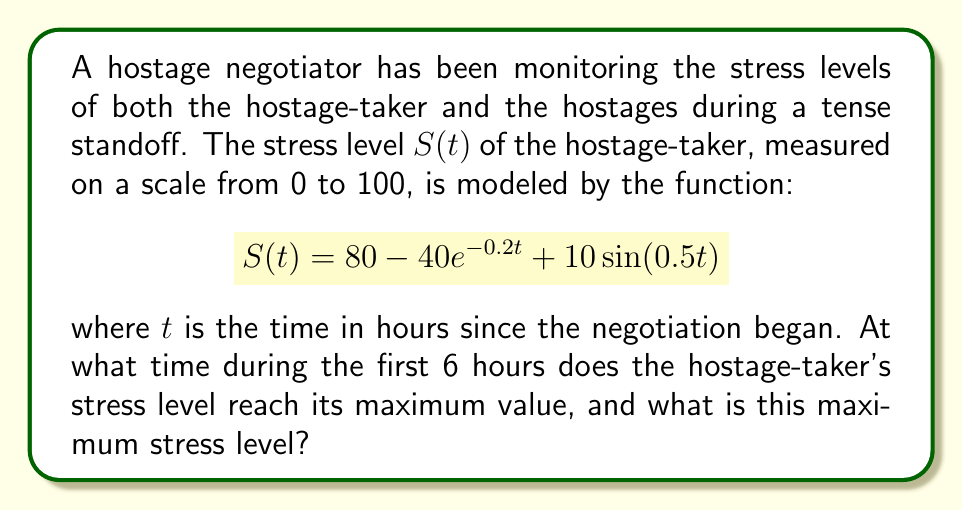Can you solve this math problem? To find the maximum stress level and when it occurs, we need to follow these steps:

1) First, we need to find the derivative of $S(t)$ with respect to $t$:
   $$S'(t) = 8e^{-0.2t} + 5\cos(0.5t)$$

2) To find the critical points, we set $S'(t) = 0$:
   $$8e^{-0.2t} + 5\cos(0.5t) = 0$$

3) This equation cannot be solved analytically, so we need to use numerical methods or graphing to find the solutions within the first 6 hours.

4) Using a graphing calculator or computer software, we can find that the first maximum occurs at approximately $t \approx 3.14$ hours.

5) To find the stress level at this time, we plug this value back into our original function:

   $$S(3.14) = 80 - 40e^{-0.2(3.14)} + 10\sin(0.5(3.14))$$
   $$\approx 80 - 40(0.5335) + 10(0.8480)$$
   $$\approx 80 - 21.34 + 8.48$$
   $$\approx 67.14$$

6) We should also check the stress level at the endpoints of our interval (0 and 6 hours):
   
   At $t=0$: $S(0) = 80 - 40 + 0 = 40$
   At $t=6$: $S(6) \approx 66.97$

7) The maximum value we found at $t \approx 3.14$ is indeed the highest in the interval [0,6].
Answer: Maximum stress level of approximately 67.14 occurs at about 3.14 hours. 